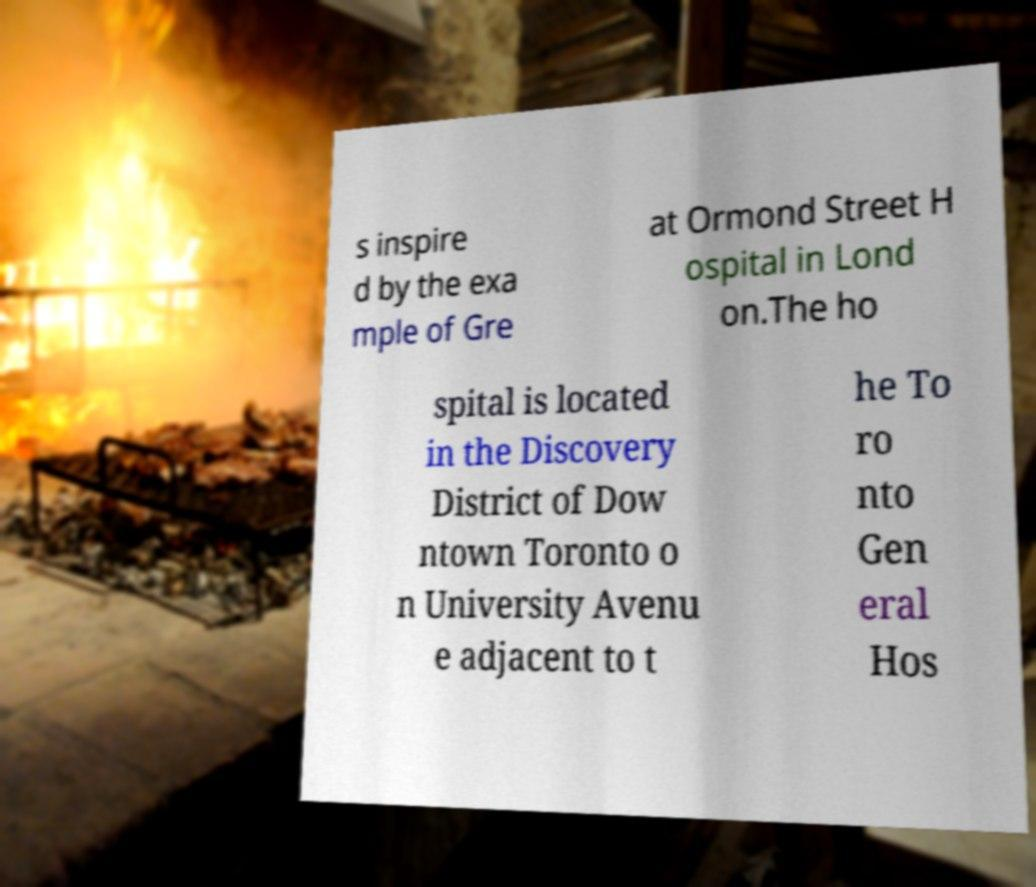Could you assist in decoding the text presented in this image and type it out clearly? s inspire d by the exa mple of Gre at Ormond Street H ospital in Lond on.The ho spital is located in the Discovery District of Dow ntown Toronto o n University Avenu e adjacent to t he To ro nto Gen eral Hos 